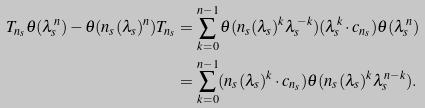Convert formula to latex. <formula><loc_0><loc_0><loc_500><loc_500>T _ { n _ { s } } \theta ( \lambda _ { s } ^ { n } ) - \theta ( n _ { s } ( \lambda _ { s } ) ^ { n } ) T _ { n _ { s } } & = \sum _ { k = 0 } ^ { n - 1 } \theta ( n _ { s } ( \lambda _ { s } ) ^ { k } \lambda _ { s } ^ { - k } ) ( \lambda _ { s } ^ { k } \cdot c _ { n _ { s } } ) \theta ( \lambda _ { s } ^ { n } ) \\ & = \sum _ { k = 0 } ^ { n - 1 } ( n _ { s } ( \lambda _ { s } ) ^ { k } \cdot c _ { n _ { s } } ) \theta ( n _ { s } ( \lambda _ { s } ) ^ { k } \lambda _ { s } ^ { n - k } ) .</formula> 